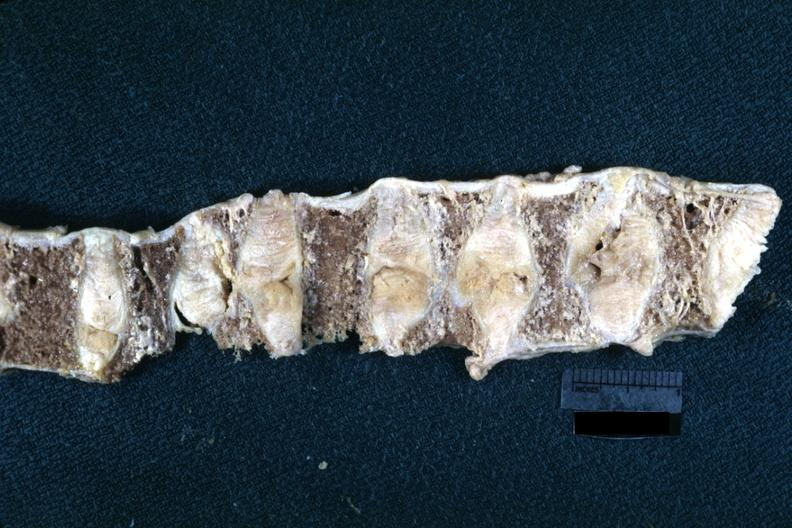what is probably due to osteoporosis?
Answer the question using a single word or phrase. This lesion 